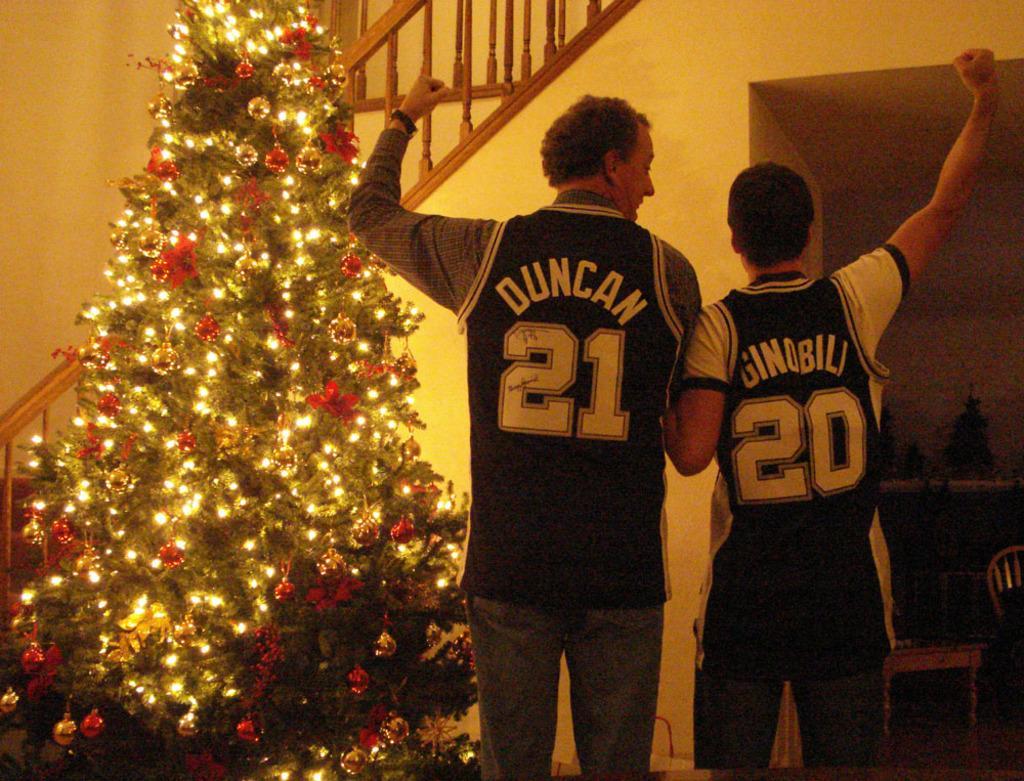Could you give a brief overview of what you see in this image? In this image there are two persons, there we can see names and numbers on the shirts, there is a Christmas tree, stairs, a chair and some objects on the table. 